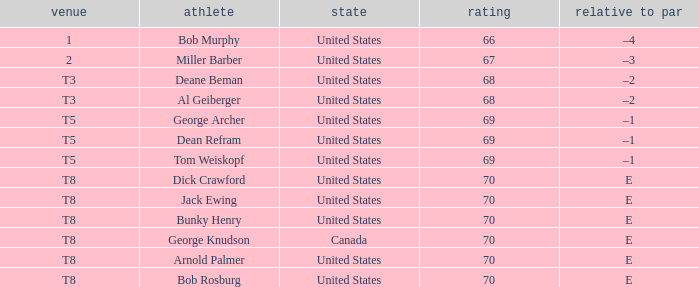When bunky henry secured t8, what was his to par? E. 